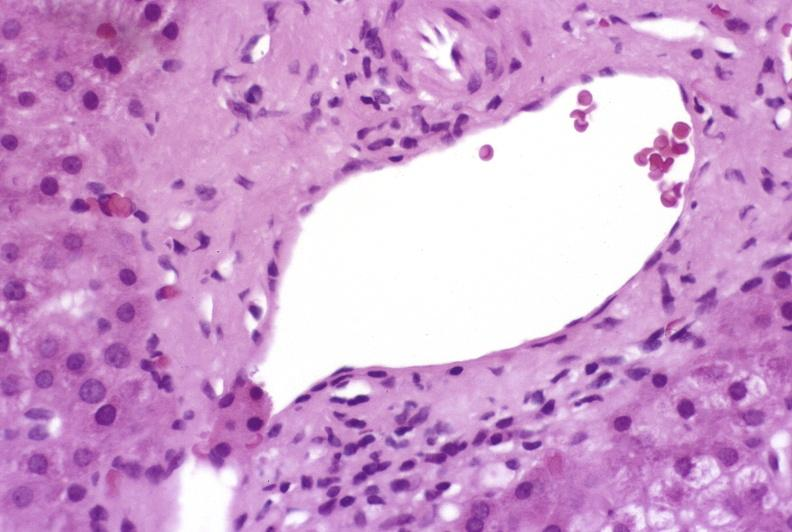does hematoma show mild-to-moderate acute rejection?
Answer the question using a single word or phrase. No 